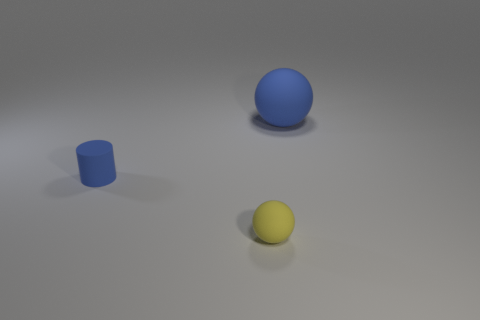There is a matte thing that is the same color as the cylinder; what is its shape?
Make the answer very short. Sphere. How many other things are there of the same color as the cylinder?
Give a very brief answer. 1. There is a matte thing that is on the right side of the matte cylinder and behind the small ball; how big is it?
Your response must be concise. Large. There is a blue matte thing that is in front of the thing that is on the right side of the tiny yellow thing; what shape is it?
Offer a very short reply. Cylinder. Is there any other thing that is the same color as the small matte cylinder?
Give a very brief answer. Yes. What shape is the big blue thing on the right side of the yellow matte ball?
Offer a very short reply. Sphere. What shape is the rubber thing that is right of the rubber cylinder and behind the small yellow rubber object?
Your answer should be very brief. Sphere. How many green objects are balls or cylinders?
Give a very brief answer. 0. Is the color of the sphere that is to the left of the big matte object the same as the large object?
Your response must be concise. No. There is a rubber ball that is behind the blue object that is in front of the big blue object; how big is it?
Your response must be concise. Large. 